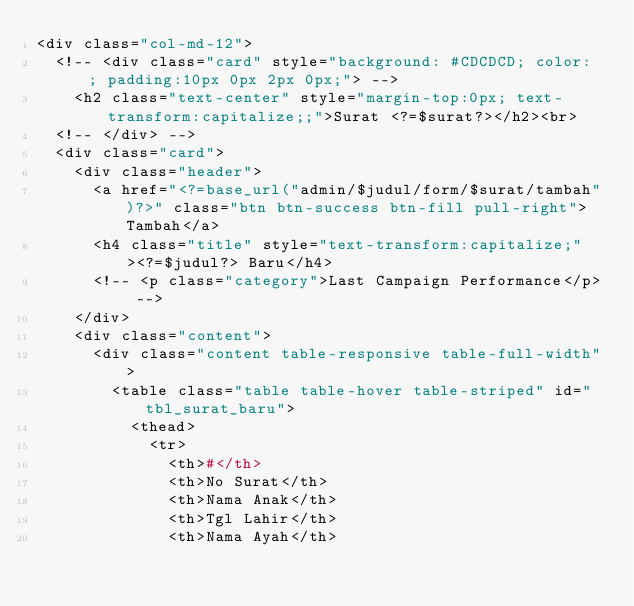<code> <loc_0><loc_0><loc_500><loc_500><_PHP_><div class="col-md-12">
	<!-- <div class="card" style="background: #CDCDCD; color: ; padding:10px 0px 2px 0px;"> -->
		<h2 class="text-center" style="margin-top:0px; text-transform:capitalize;;">Surat <?=$surat?></h2><br>
	<!-- </div> -->
	<div class="card">
		<div class="header">
			<a href="<?=base_url("admin/$judul/form/$surat/tambah")?>" class="btn btn-success btn-fill pull-right">Tambah</a>
			<h4 class="title" style="text-transform:capitalize;"><?=$judul?> Baru</h4>
			<!-- <p class="category">Last Campaign Performance</p> -->
		</div>
		<div class="content">
			<div class="content table-responsive table-full-width">
				<table class="table table-hover table-striped" id="tbl_surat_baru">
					<thead>
						<tr>
							<th>#</th>
							<th>No Surat</th>
							<th>Nama Anak</th>
							<th>Tgl Lahir</th>
							<th>Nama Ayah</th></code> 